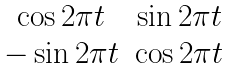<formula> <loc_0><loc_0><loc_500><loc_500>\begin{matrix} \cos 2 \pi t & \sin 2 \pi t \\ - \sin 2 \pi t & \cos 2 \pi t \end{matrix}</formula> 